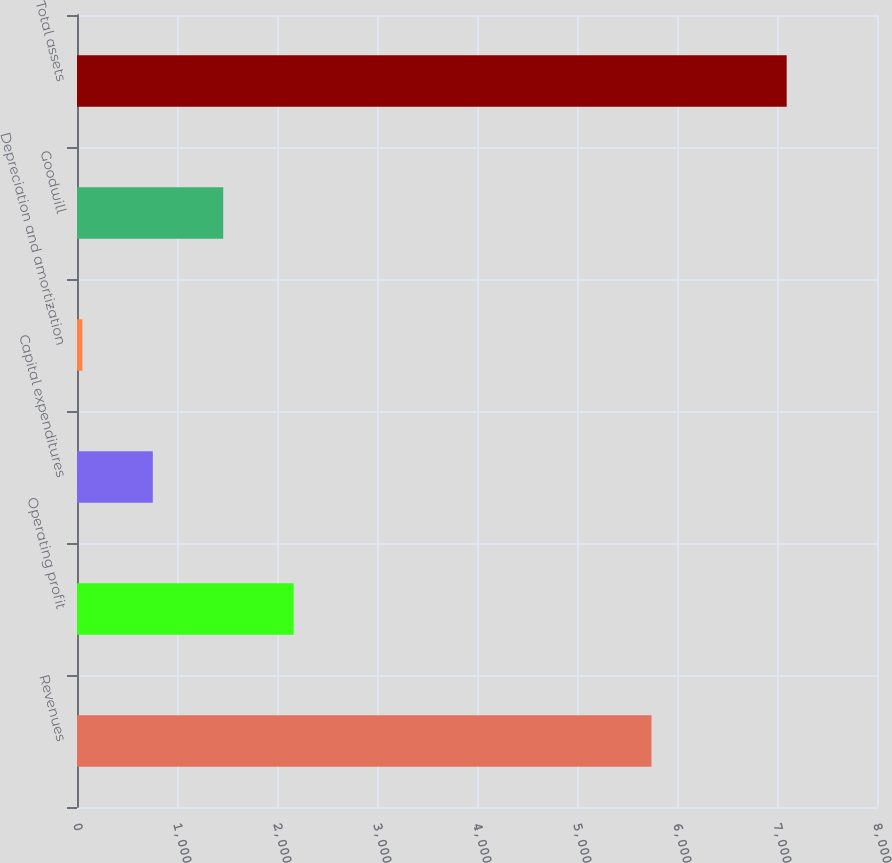Convert chart. <chart><loc_0><loc_0><loc_500><loc_500><bar_chart><fcel>Revenues<fcel>Operating profit<fcel>Capital expenditures<fcel>Depreciation and amortization<fcel>Goodwill<fcel>Total assets<nl><fcel>5744.7<fcel>2166.63<fcel>758.01<fcel>53.7<fcel>1462.32<fcel>7096.8<nl></chart> 